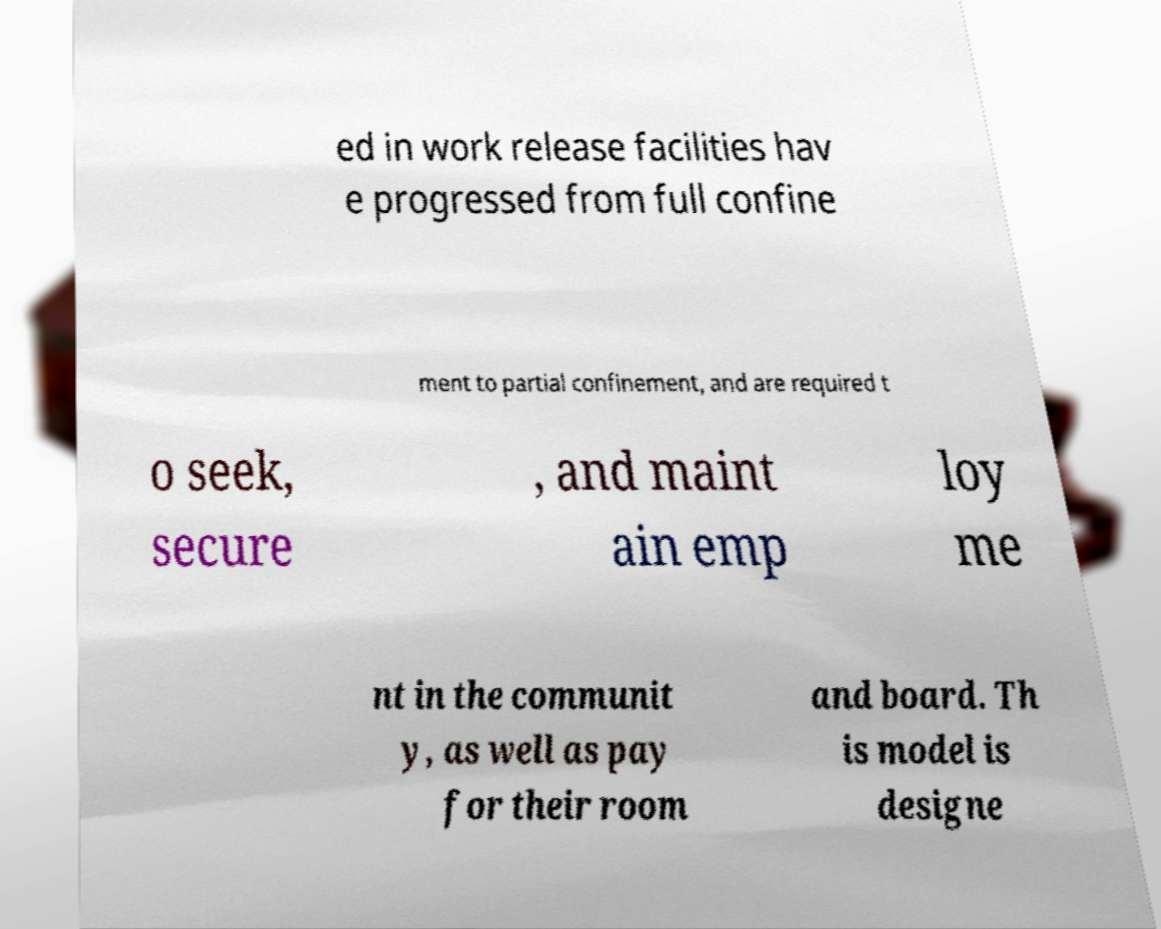Could you extract and type out the text from this image? ed in work release facilities hav e progressed from full confine ment to partial confinement, and are required t o seek, secure , and maint ain emp loy me nt in the communit y, as well as pay for their room and board. Th is model is designe 